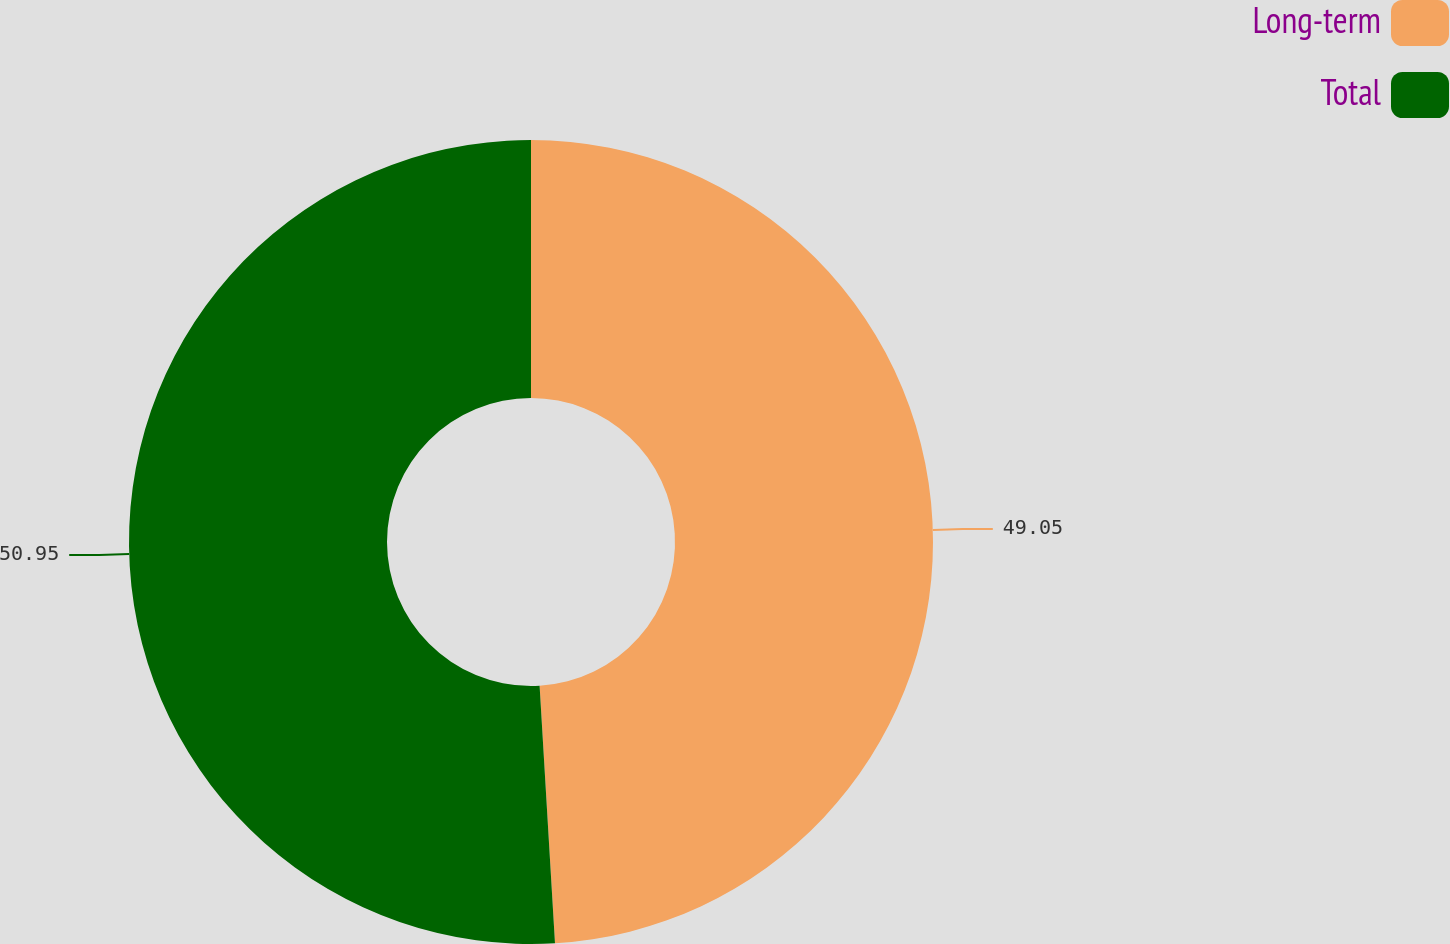<chart> <loc_0><loc_0><loc_500><loc_500><pie_chart><fcel>Long-term<fcel>Total<nl><fcel>49.05%<fcel>50.95%<nl></chart> 